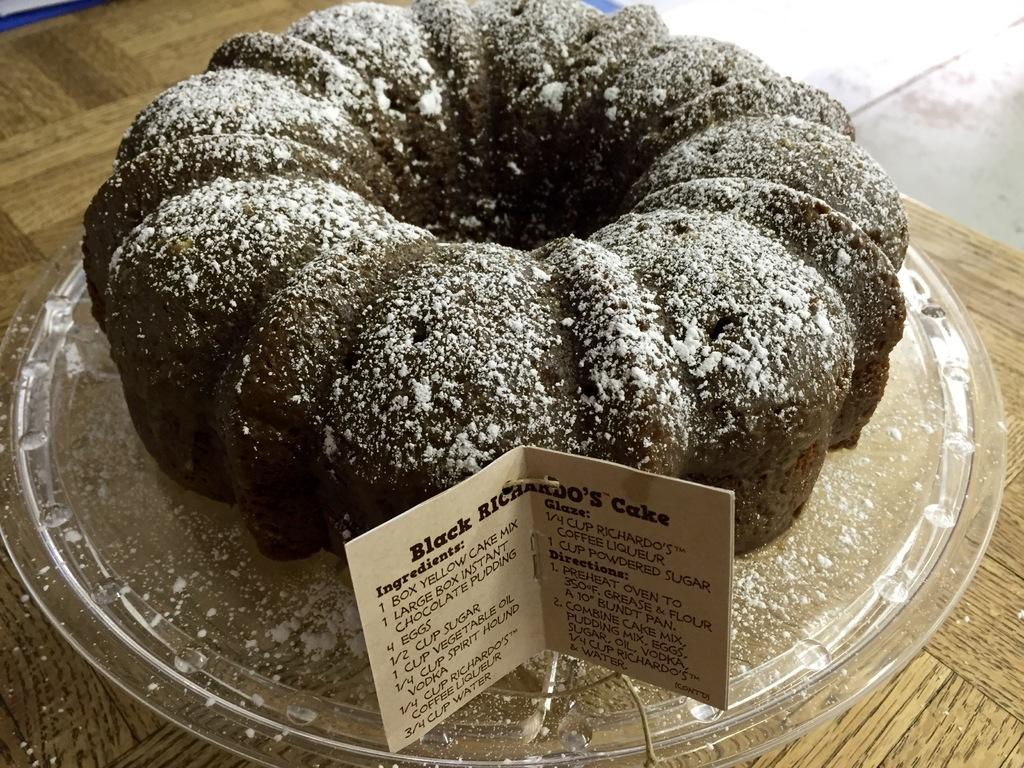What is the main subject of the image? The main subject of the image is a cake. How is the cake being supported or contained in the image? The cake is in a tray. What additional object is present in the image besides the cake and tray? There is a tag with text in the image. Where is the tag located in the image? The tag is on a wooden table. Can you tell me how many mailboxes are visible in the image? There are no mailboxes present in the image. What type of rule is being enforced in the wilderness depicted in the image? There is no wilderness depicted in the image, and therefore no rules related to it can be observed. 